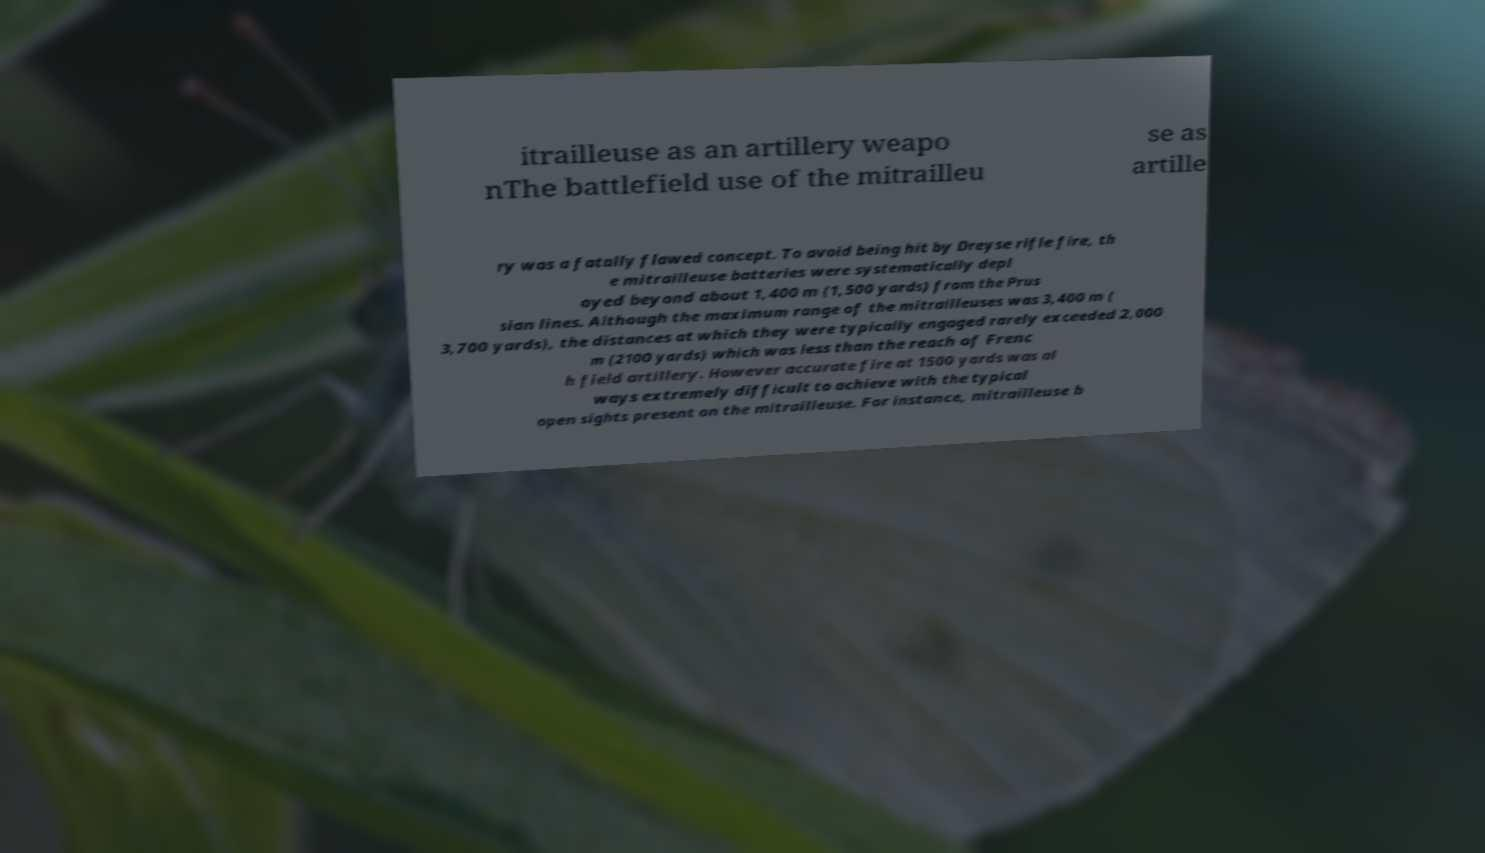For documentation purposes, I need the text within this image transcribed. Could you provide that? itrailleuse as an artillery weapo nThe battlefield use of the mitrailleu se as artille ry was a fatally flawed concept. To avoid being hit by Dreyse rifle fire, th e mitrailleuse batteries were systematically depl oyed beyond about 1,400 m (1,500 yards) from the Prus sian lines. Although the maximum range of the mitrailleuses was 3,400 m ( 3,700 yards), the distances at which they were typically engaged rarely exceeded 2,000 m (2100 yards) which was less than the reach of Frenc h field artillery. However accurate fire at 1500 yards was al ways extremely difficult to achieve with the typical open sights present on the mitrailleuse. For instance, mitrailleuse b 